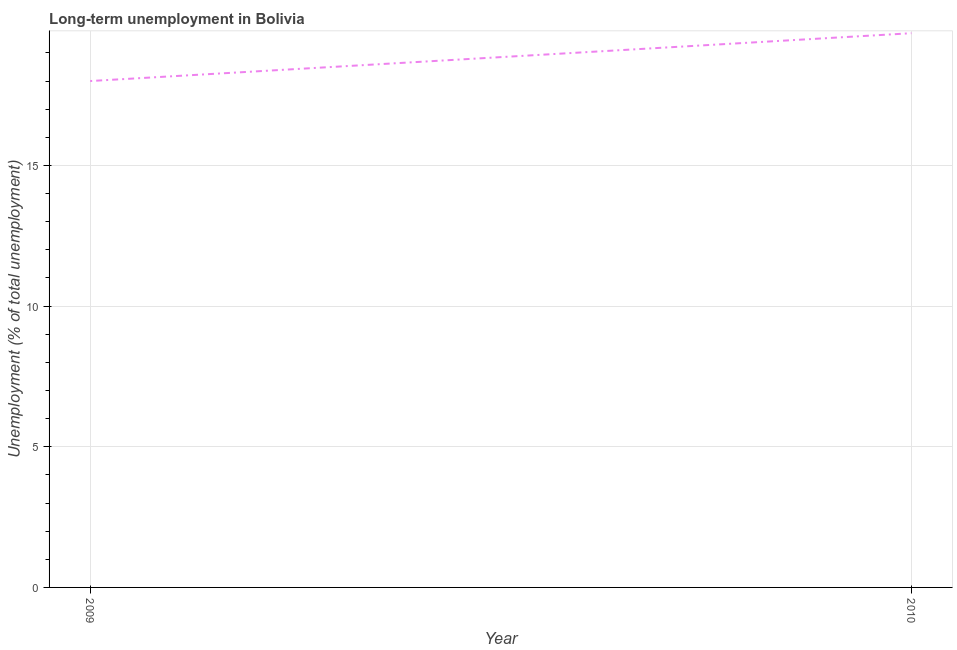What is the long-term unemployment in 2009?
Keep it short and to the point. 18. Across all years, what is the maximum long-term unemployment?
Your response must be concise. 19.7. In which year was the long-term unemployment maximum?
Make the answer very short. 2010. In which year was the long-term unemployment minimum?
Your answer should be very brief. 2009. What is the sum of the long-term unemployment?
Provide a short and direct response. 37.7. What is the difference between the long-term unemployment in 2009 and 2010?
Provide a short and direct response. -1.7. What is the average long-term unemployment per year?
Keep it short and to the point. 18.85. What is the median long-term unemployment?
Ensure brevity in your answer.  18.85. Do a majority of the years between 2009 and 2010 (inclusive) have long-term unemployment greater than 2 %?
Keep it short and to the point. Yes. What is the ratio of the long-term unemployment in 2009 to that in 2010?
Your response must be concise. 0.91. Does the long-term unemployment monotonically increase over the years?
Offer a terse response. Yes. How many years are there in the graph?
Make the answer very short. 2. What is the difference between two consecutive major ticks on the Y-axis?
Give a very brief answer. 5. Does the graph contain grids?
Offer a terse response. Yes. What is the title of the graph?
Offer a terse response. Long-term unemployment in Bolivia. What is the label or title of the Y-axis?
Provide a succinct answer. Unemployment (% of total unemployment). What is the Unemployment (% of total unemployment) in 2010?
Your response must be concise. 19.7. What is the difference between the Unemployment (% of total unemployment) in 2009 and 2010?
Keep it short and to the point. -1.7. What is the ratio of the Unemployment (% of total unemployment) in 2009 to that in 2010?
Provide a short and direct response. 0.91. 